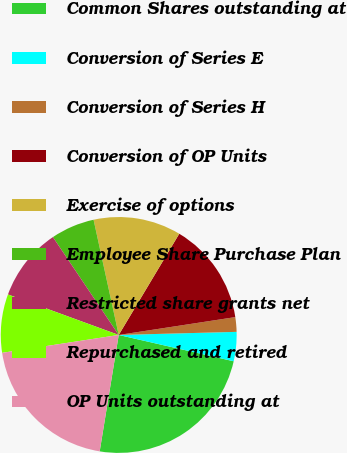<chart> <loc_0><loc_0><loc_500><loc_500><pie_chart><fcel>Common Shares outstanding at<fcel>Conversion of Series E<fcel>Conversion of Series H<fcel>Conversion of OP Units<fcel>Exercise of options<fcel>Employee Share Purchase Plan<fcel>Restricted share grants net<fcel>Repurchased and retired<fcel>OP Units outstanding at<nl><fcel>24.0%<fcel>4.0%<fcel>2.0%<fcel>14.0%<fcel>12.0%<fcel>6.0%<fcel>10.0%<fcel>8.0%<fcel>20.0%<nl></chart> 